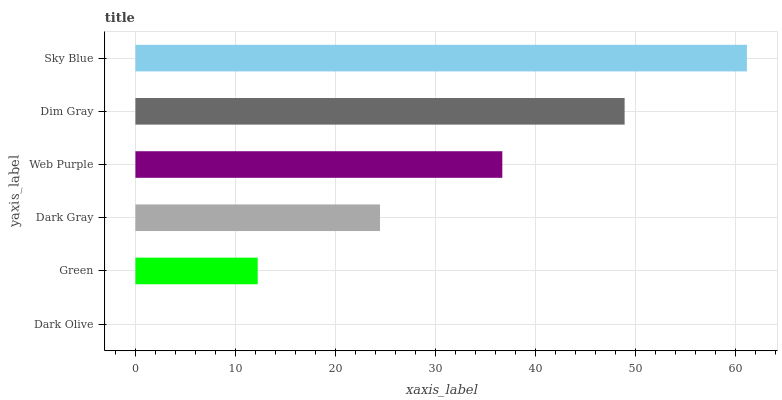Is Dark Olive the minimum?
Answer yes or no. Yes. Is Sky Blue the maximum?
Answer yes or no. Yes. Is Green the minimum?
Answer yes or no. No. Is Green the maximum?
Answer yes or no. No. Is Green greater than Dark Olive?
Answer yes or no. Yes. Is Dark Olive less than Green?
Answer yes or no. Yes. Is Dark Olive greater than Green?
Answer yes or no. No. Is Green less than Dark Olive?
Answer yes or no. No. Is Web Purple the high median?
Answer yes or no. Yes. Is Dark Gray the low median?
Answer yes or no. Yes. Is Sky Blue the high median?
Answer yes or no. No. Is Dim Gray the low median?
Answer yes or no. No. 